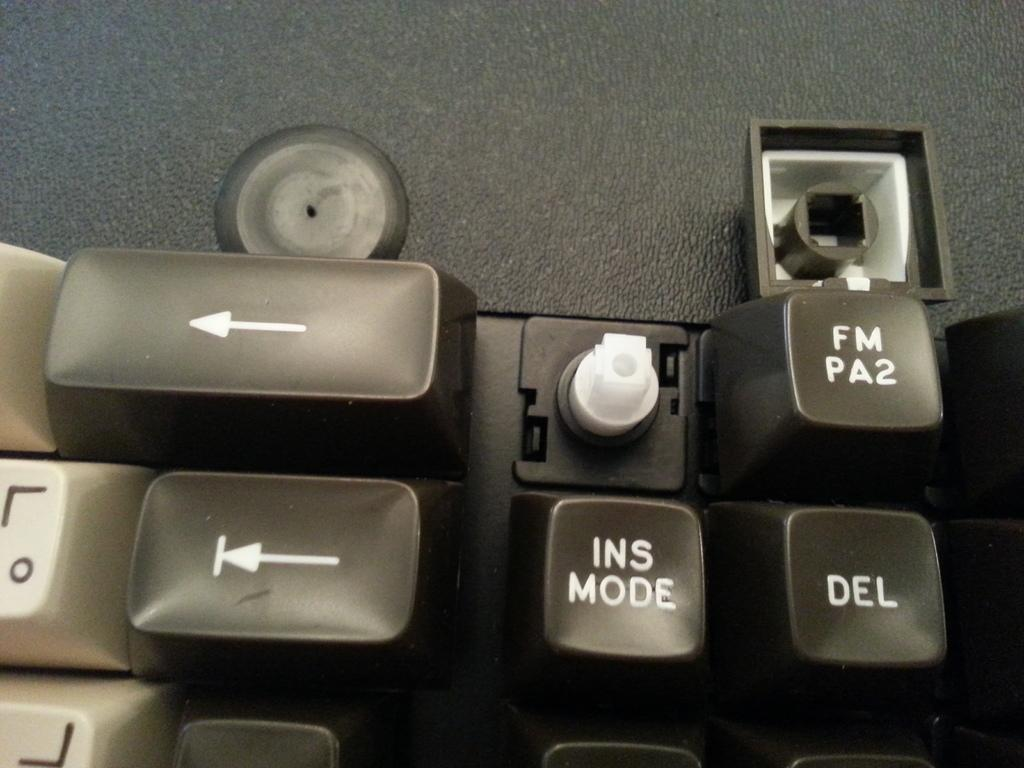<image>
Relay a brief, clear account of the picture shown. A black keyboard with the letters in white is missing a key over the ins mode key. 